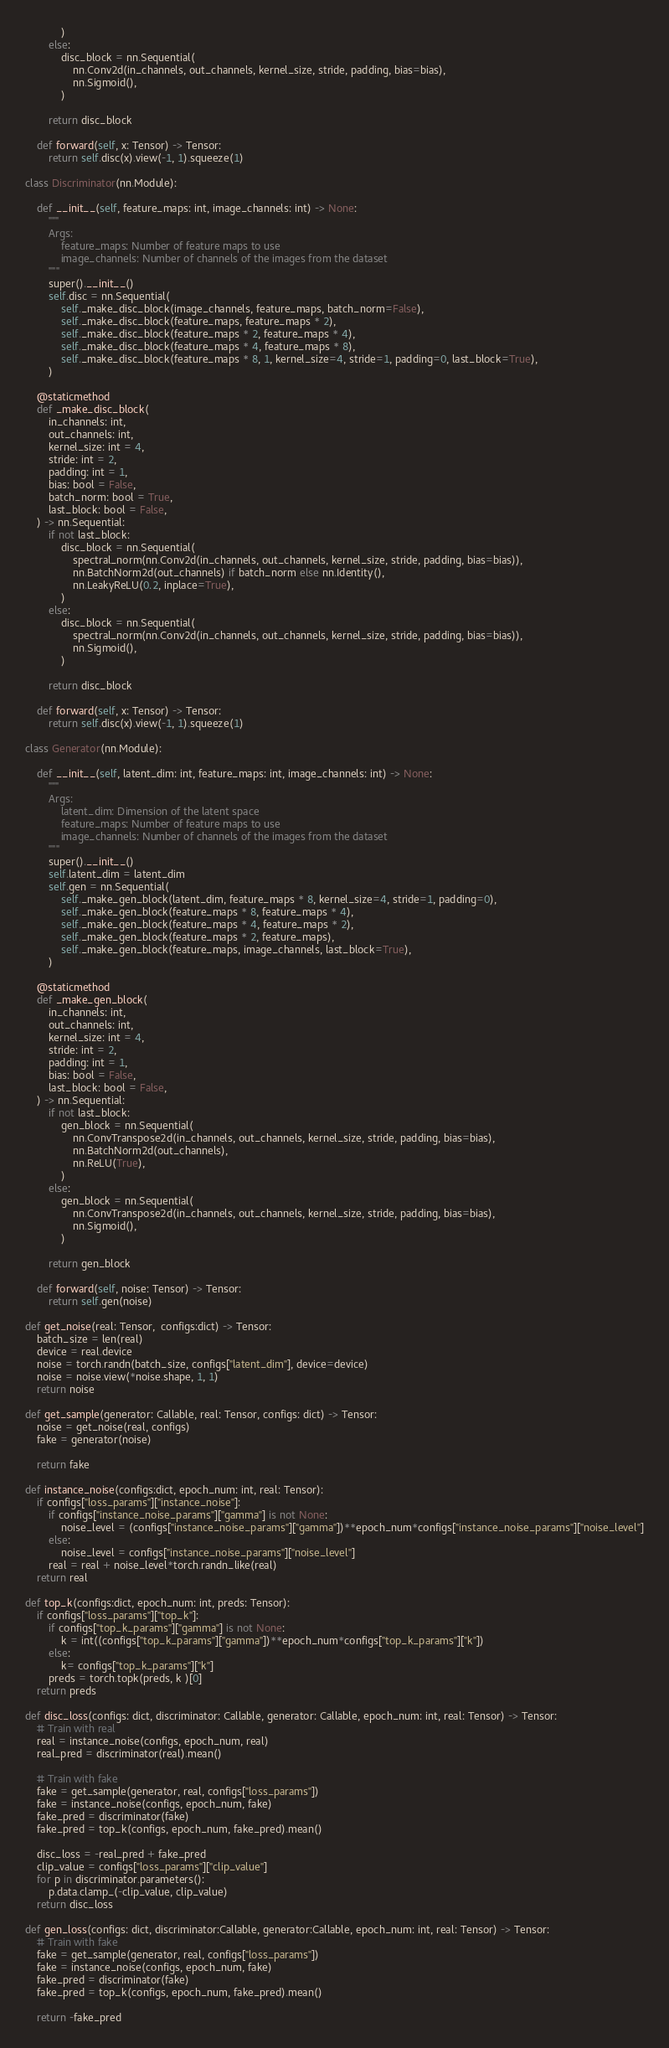<code> <loc_0><loc_0><loc_500><loc_500><_Python_>            )
        else:
            disc_block = nn.Sequential(
                nn.Conv2d(in_channels, out_channels, kernel_size, stride, padding, bias=bias),
                nn.Sigmoid(),
            )

        return disc_block

    def forward(self, x: Tensor) -> Tensor:
        return self.disc(x).view(-1, 1).squeeze(1)

class Discriminator(nn.Module):

    def __init__(self, feature_maps: int, image_channels: int) -> None:
        """
        Args:
            feature_maps: Number of feature maps to use
            image_channels: Number of channels of the images from the dataset
        """
        super().__init__()
        self.disc = nn.Sequential(
            self._make_disc_block(image_channels, feature_maps, batch_norm=False),
            self._make_disc_block(feature_maps, feature_maps * 2),
            self._make_disc_block(feature_maps * 2, feature_maps * 4),
            self._make_disc_block(feature_maps * 4, feature_maps * 8),
            self._make_disc_block(feature_maps * 8, 1, kernel_size=4, stride=1, padding=0, last_block=True),
        )

    @staticmethod
    def _make_disc_block(
        in_channels: int,
        out_channels: int,
        kernel_size: int = 4,
        stride: int = 2,
        padding: int = 1,
        bias: bool = False,
        batch_norm: bool = True,
        last_block: bool = False,
    ) -> nn.Sequential:
        if not last_block:
            disc_block = nn.Sequential(
                spectral_norm(nn.Conv2d(in_channels, out_channels, kernel_size, stride, padding, bias=bias)),
                nn.BatchNorm2d(out_channels) if batch_norm else nn.Identity(),
                nn.LeakyReLU(0.2, inplace=True),
            )
        else:
            disc_block = nn.Sequential(
                spectral_norm(nn.Conv2d(in_channels, out_channels, kernel_size, stride, padding, bias=bias)),
                nn.Sigmoid(),
            )

        return disc_block

    def forward(self, x: Tensor) -> Tensor:
        return self.disc(x).view(-1, 1).squeeze(1)

class Generator(nn.Module):

    def __init__(self, latent_dim: int, feature_maps: int, image_channels: int) -> None:
        """
        Args:
            latent_dim: Dimension of the latent space
            feature_maps: Number of feature maps to use
            image_channels: Number of channels of the images from the dataset
        """
        super().__init__()
        self.latent_dim = latent_dim
        self.gen = nn.Sequential(
            self._make_gen_block(latent_dim, feature_maps * 8, kernel_size=4, stride=1, padding=0),
            self._make_gen_block(feature_maps * 8, feature_maps * 4),
            self._make_gen_block(feature_maps * 4, feature_maps * 2),
            self._make_gen_block(feature_maps * 2, feature_maps),
            self._make_gen_block(feature_maps, image_channels, last_block=True),
        )

    @staticmethod
    def _make_gen_block(
        in_channels: int,
        out_channels: int,
        kernel_size: int = 4,
        stride: int = 2,
        padding: int = 1,
        bias: bool = False,
        last_block: bool = False,
    ) -> nn.Sequential:
        if not last_block:
            gen_block = nn.Sequential(
                nn.ConvTranspose2d(in_channels, out_channels, kernel_size, stride, padding, bias=bias),
                nn.BatchNorm2d(out_channels),
                nn.ReLU(True),
            )
        else:
            gen_block = nn.Sequential(
                nn.ConvTranspose2d(in_channels, out_channels, kernel_size, stride, padding, bias=bias),
                nn.Sigmoid(),
            )

        return gen_block

    def forward(self, noise: Tensor) -> Tensor:
        return self.gen(noise)

def get_noise(real: Tensor,  configs:dict) -> Tensor:
    batch_size = len(real)
    device = real.device
    noise = torch.randn(batch_size, configs["latent_dim"], device=device)
    noise = noise.view(*noise.shape, 1, 1)
    return noise 

def get_sample(generator: Callable, real: Tensor, configs: dict) -> Tensor:
    noise = get_noise(real, configs)
    fake = generator(noise)

    return fake

def instance_noise(configs:dict, epoch_num: int, real: Tensor):
    if configs["loss_params"]["instance_noise"]:
        if configs["instance_noise_params"]["gamma"] is not None:
            noise_level = (configs["instance_noise_params"]["gamma"])**epoch_num*configs["instance_noise_params"]["noise_level"]
        else:
            noise_level = configs["instance_noise_params"]["noise_level"]
        real = real + noise_level*torch.randn_like(real)
    return real 

def top_k(configs:dict, epoch_num: int, preds: Tensor):
    if configs["loss_params"]["top_k"]:
        if configs["top_k_params"]["gamma"] is not None:
            k = int((configs["top_k_params"]["gamma"])**epoch_num*configs["top_k_params"]["k"])
        else:
            k= configs["top_k_params"]["k"]
        preds = torch.topk(preds, k )[0]
    return preds

def disc_loss(configs: dict, discriminator: Callable, generator: Callable, epoch_num: int, real: Tensor) -> Tensor:
    # Train with real
    real = instance_noise(configs, epoch_num, real)
    real_pred = discriminator(real).mean()

    # Train with fake
    fake = get_sample(generator, real, configs["loss_params"])
    fake = instance_noise(configs, epoch_num, fake)
    fake_pred = discriminator(fake)
    fake_pred = top_k(configs, epoch_num, fake_pred).mean()
    
    disc_loss = -real_pred + fake_pred 
    clip_value = configs["loss_params"]["clip_value"]
    for p in discriminator.parameters():
        p.data.clamp_(-clip_value, clip_value)
    return disc_loss

def gen_loss(configs: dict, discriminator:Callable, generator:Callable, epoch_num: int, real: Tensor) -> Tensor:
    # Train with fake
    fake = get_sample(generator, real, configs["loss_params"])
    fake = instance_noise(configs, epoch_num, fake)
    fake_pred = discriminator(fake)
    fake_pred = top_k(configs, epoch_num, fake_pred).mean()

    return -fake_pred 
</code> 